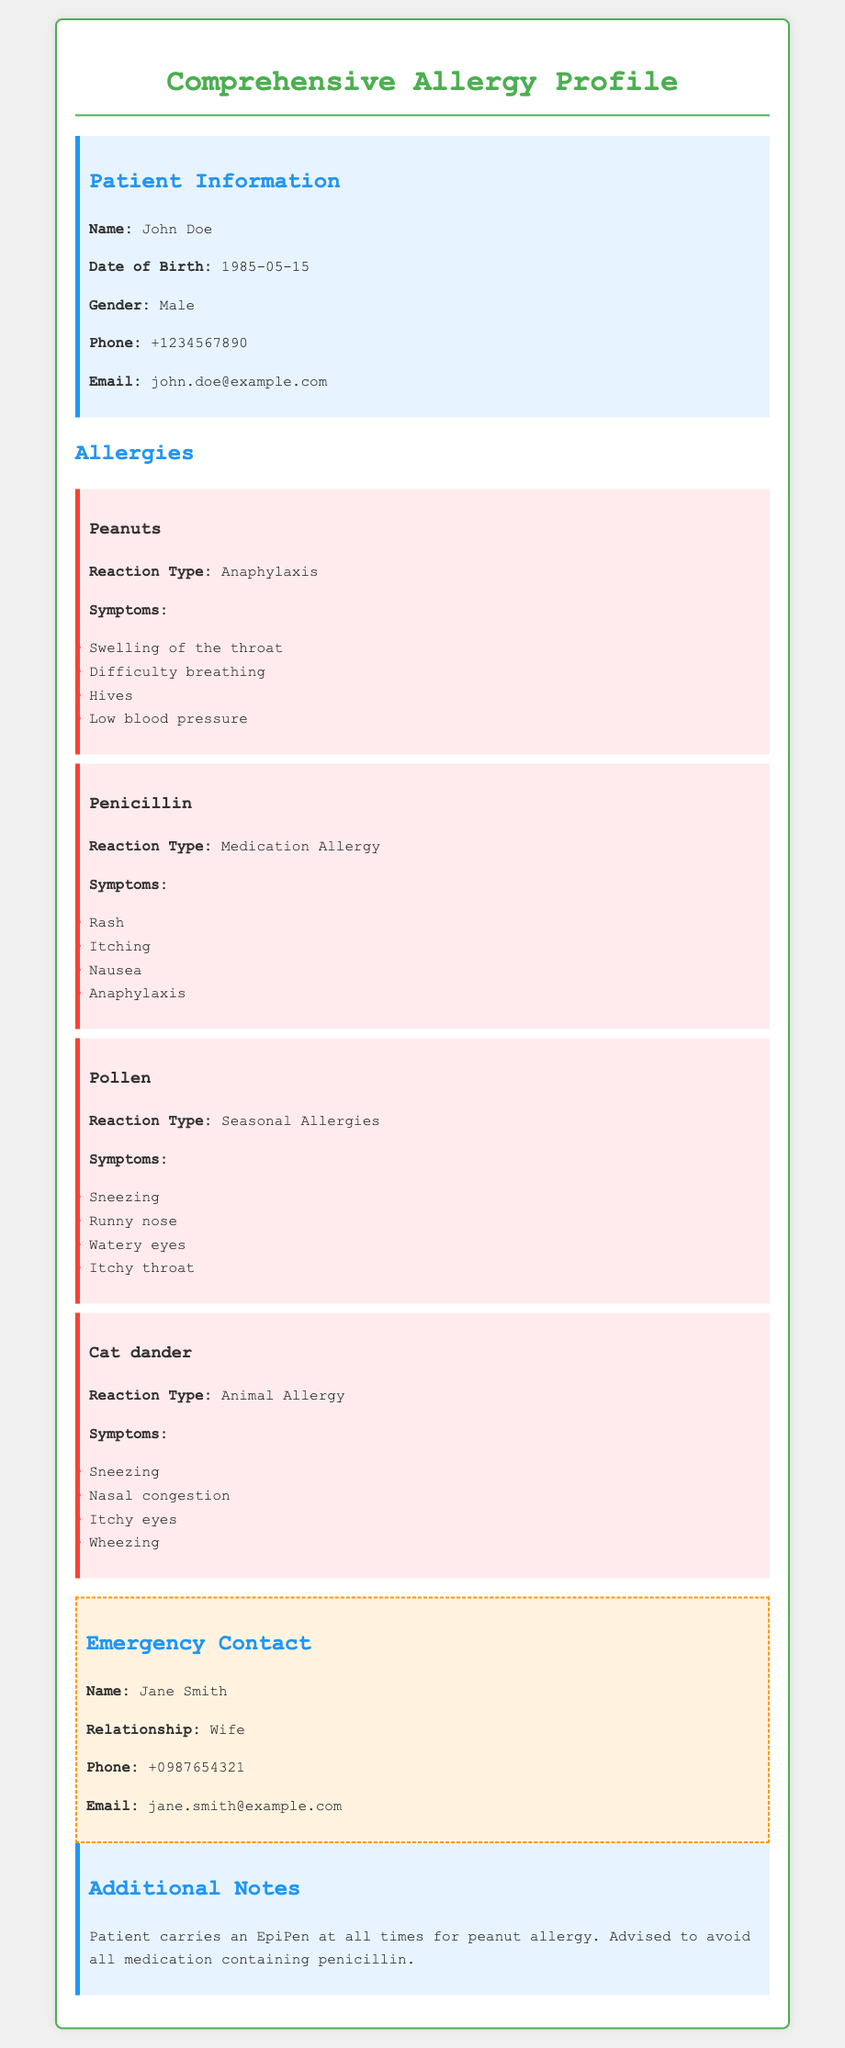What is the patient's name? The patient's name is provided in the Patient Information section of the document.
Answer: John Doe What is the reaction type for peanut allergy? The reaction type is detailed under the Peanuts allergy item in the document.
Answer: Anaphylaxis How many symptoms are listed for the pollen allergy? The number of symptoms can be counted from the symptoms listed under the Pollen allergy item.
Answer: Four What is the emergency contact's relationship to the patient? The relationship is specified in the Emergency Contact section of the document.
Answer: Wife What medication should the patient avoid? The medication to avoid is noted in the Additional Notes section at the end of the document.
Answer: Penicillin What is the phone number of the emergency contact? The emergency contact's phone number is provided in the Emergency Contact section.
Answer: +0987654321 What type of allergy is associated with cat dander? The type of allergy is mentioned under the Cat dander allergy item in the document.
Answer: Animal Allergy What does the patient carry for their peanut allergy? This information is found in the Additional Notes section regarding the patient's peanut allergy management.
Answer: EpiPen 